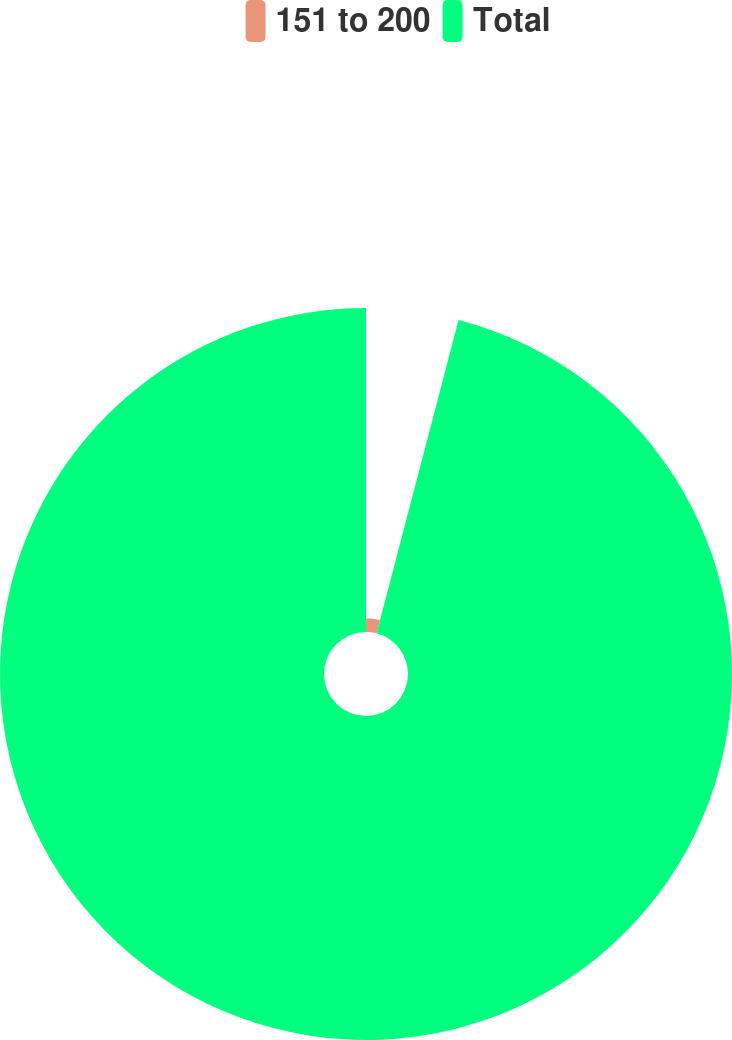Convert chart to OTSL. <chart><loc_0><loc_0><loc_500><loc_500><pie_chart><fcel>151 to 200<fcel>Total<nl><fcel>4.07%<fcel>95.93%<nl></chart> 